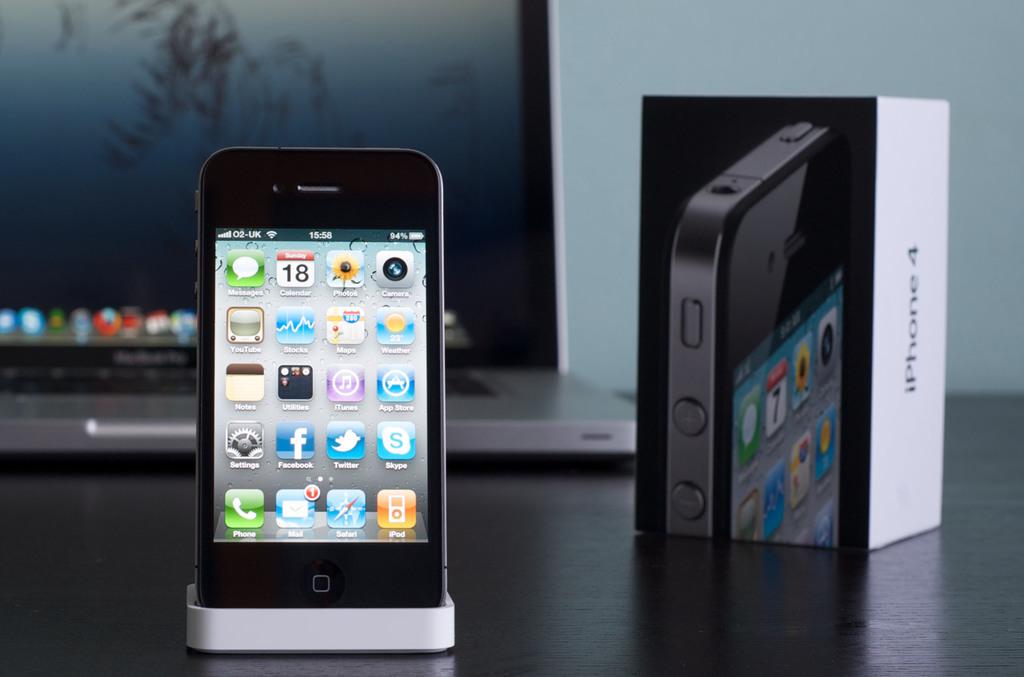What is the brand of this phone?
Your answer should be very brief. Iphone. What number is on the app on the phone?
Offer a very short reply. 18. 